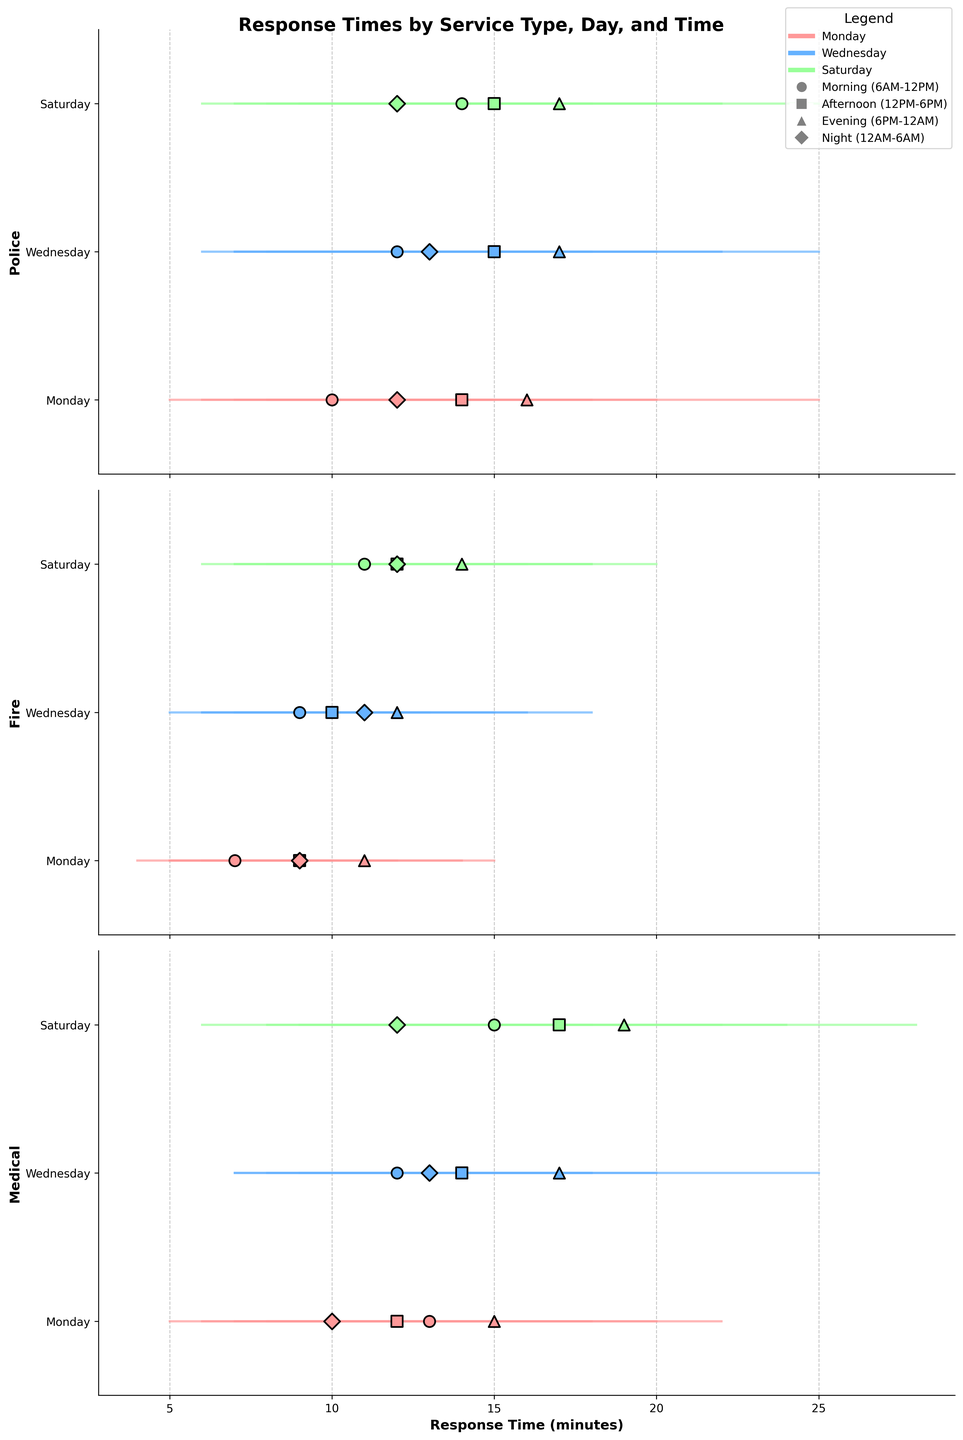What's the title of the figure? The title of the figure is at the top and it describes the content of the plot. It states "Response Times by Service Type, Day, and Time" which indicates the focus of the plot.
Answer: Response Times by Service Type, Day, and Time How are days of the week differentiated in the plot? Days of the week are represented by different colors in the plot. Monday is shown in a reddish color, Wednesday in a blueish color, and Saturday in a greenish color, according to the legend in the plot.
Answer: With different colors What is the response time range for police services on Monday mornings? Look at the section for police response times. Find the horizontal lines marked for "Monday" under the police section during the "Morning (6AM-12PM)". The minimum and maximum values are 5 and 15 minutes, respectively.
Answer: 5 to 15 minutes Which service type has the longest maximum response time on Saturday evenings? Focus on the "Evening (6PM-12AM)" section for Saturday across all service types. Compare the maximum response times: Police (25 mins), Fire (20 mins), Medical (28 mins). The highest value belongs to Medical services.
Answer: Medical What is the average response time for fire services on Wednesday nights? Locate the "Fire" section of the plot under "Wednesday" during the "Night (12AM-6AM)". The average response time is shown by the dot in the line: it's 11 minutes.
Answer: 11 minutes Which day and time block has the lowest minimum response time for medical services? Analyze the sections under "Medical" service type, comparing weekday and time blocks for the lowest minimum value. Monday morning has the lowest minimum of 5 minutes.
Answer: Monday morning On Wednesday afternoons, which service type has the highest average response time? Look at "Wednesday" under "Afternoon (12PM-6PM)" for all services. The average points are at: Police (15 mins), Fire (10 mins), Medical (14 mins). Police has the highest average response time.
Answer: Police Are the response times for fire services on Saturday evenings generally higher or lower than on Wednesday evenings? Compare the ranges (start to end of the lines) for Fire services on Saturday and Wednesday evenings. Saturday (8 to 20 mins), Wednesday (7 to 18 mins). Saturday's range is slightly higher.
Answer: Higher What is the difference between the maximum response times for police services on Monday afternoons and Wednesday afternoons? Look at the max values in the Police section for Monday and Wednesday afternoons. Monday's max is 20 minutes and Wednesday's max is 22 minutes. So, the difference is 22 - 20 = 2 minutes.
Answer: 2 minutes How can the morning (6AM-12PM) and night (12AM-6AM) response times for medical services on Saturday be visually compared? Check the dots and lines for Medical services on Saturday for both the morning and night time blocks. Morning ranges from 8 to 22 mins with average 15 mins, night ranges from 6 to 18 mins with average 12 mins. Visual comparison shows morning times are generally higher.
Answer: Morning is generally higher 